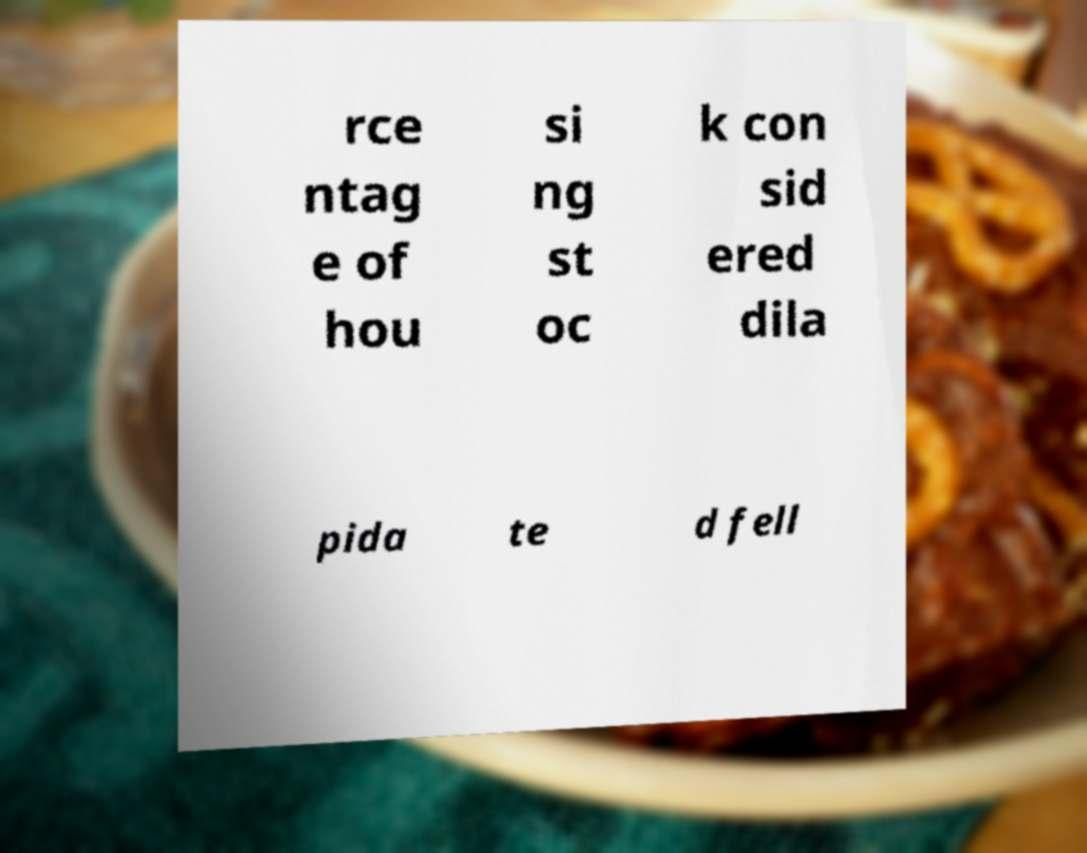Can you accurately transcribe the text from the provided image for me? rce ntag e of hou si ng st oc k con sid ered dila pida te d fell 